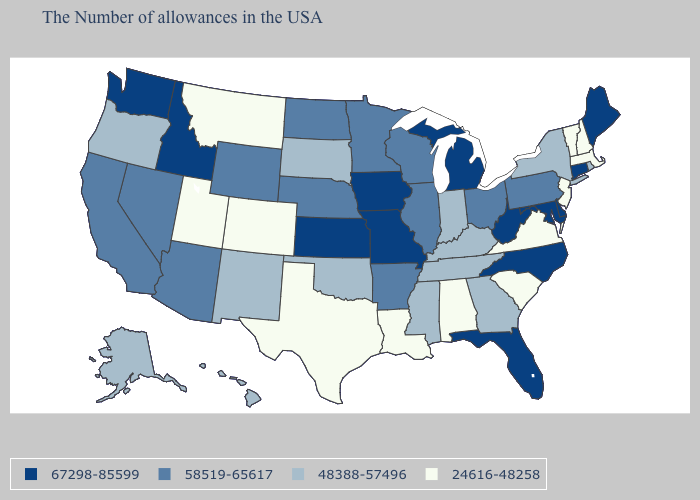What is the highest value in the Northeast ?
Answer briefly. 67298-85599. Among the states that border West Virginia , does Maryland have the lowest value?
Quick response, please. No. What is the value of Colorado?
Answer briefly. 24616-48258. Name the states that have a value in the range 58519-65617?
Concise answer only. Pennsylvania, Ohio, Wisconsin, Illinois, Arkansas, Minnesota, Nebraska, North Dakota, Wyoming, Arizona, Nevada, California. What is the highest value in the USA?
Give a very brief answer. 67298-85599. What is the highest value in the West ?
Keep it brief. 67298-85599. Which states have the lowest value in the USA?
Concise answer only. Massachusetts, New Hampshire, Vermont, New Jersey, Virginia, South Carolina, Alabama, Louisiana, Texas, Colorado, Utah, Montana. Does Delaware have the same value as Texas?
Keep it brief. No. How many symbols are there in the legend?
Short answer required. 4. What is the value of Minnesota?
Write a very short answer. 58519-65617. Among the states that border Tennessee , which have the lowest value?
Give a very brief answer. Virginia, Alabama. Name the states that have a value in the range 24616-48258?
Short answer required. Massachusetts, New Hampshire, Vermont, New Jersey, Virginia, South Carolina, Alabama, Louisiana, Texas, Colorado, Utah, Montana. Name the states that have a value in the range 24616-48258?
Quick response, please. Massachusetts, New Hampshire, Vermont, New Jersey, Virginia, South Carolina, Alabama, Louisiana, Texas, Colorado, Utah, Montana. Does Oregon have the lowest value in the West?
Short answer required. No. 